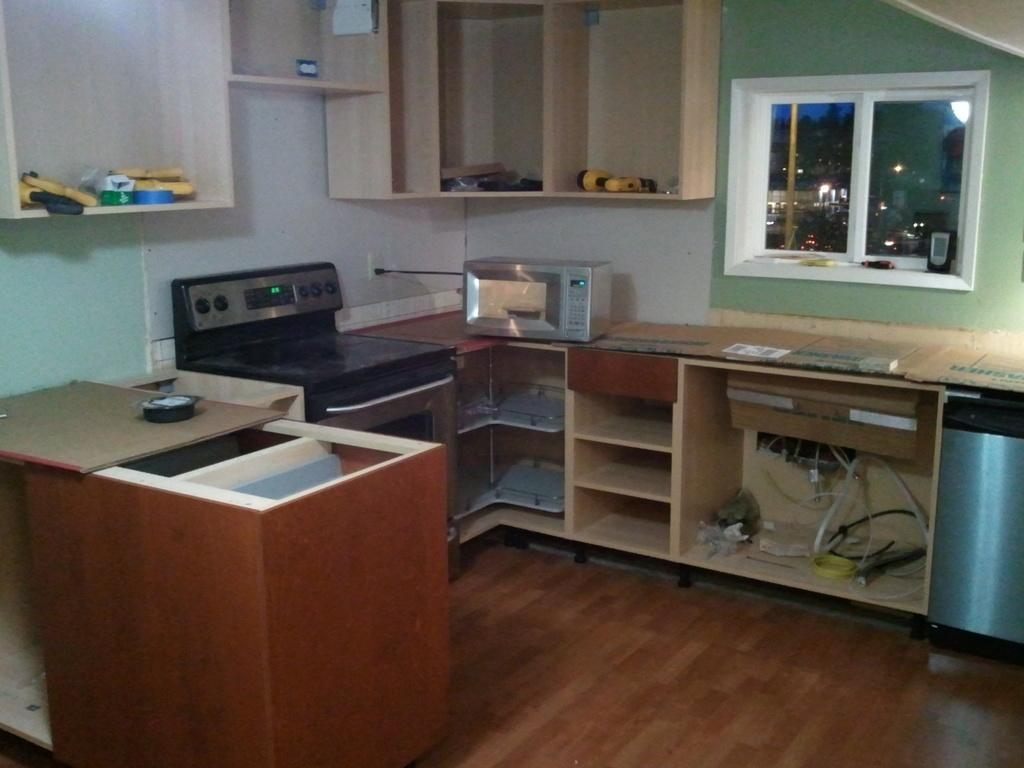What type of cooking appliance is present in the image? There is a gas stove in the image. Are there any other cooking appliances visible? Yes, there is an oven in the image. Where are the gas stove and oven located? Both the gas stove and oven are on a table. What can be seen in the background of the image? There is a window in the image. How is the window positioned in relation to the gas stove and oven? The window is located between the gas stove and oven. What color crayon is being used to draw on the gas stove in the image? There are no crayons or drawings present in the image; it features a gas stove and oven on a table with a window in the background. 